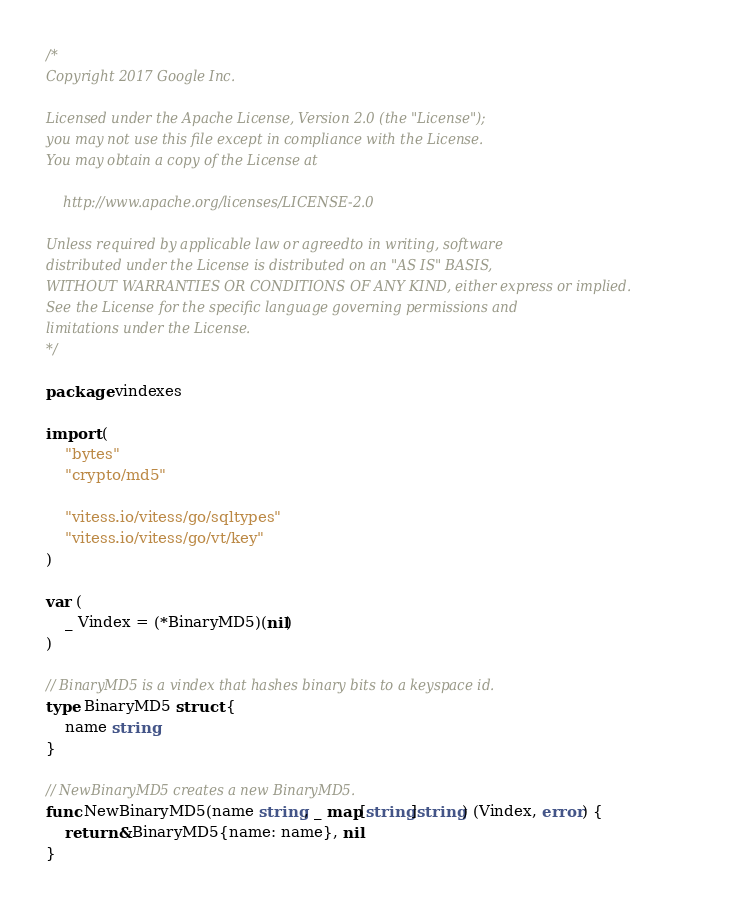Convert code to text. <code><loc_0><loc_0><loc_500><loc_500><_Go_>/*
Copyright 2017 Google Inc.

Licensed under the Apache License, Version 2.0 (the "License");
you may not use this file except in compliance with the License.
You may obtain a copy of the License at

    http://www.apache.org/licenses/LICENSE-2.0

Unless required by applicable law or agreedto in writing, software
distributed under the License is distributed on an "AS IS" BASIS,
WITHOUT WARRANTIES OR CONDITIONS OF ANY KIND, either express or implied.
See the License for the specific language governing permissions and
limitations under the License.
*/

package vindexes

import (
	"bytes"
	"crypto/md5"

	"vitess.io/vitess/go/sqltypes"
	"vitess.io/vitess/go/vt/key"
)

var (
	_ Vindex = (*BinaryMD5)(nil)
)

// BinaryMD5 is a vindex that hashes binary bits to a keyspace id.
type BinaryMD5 struct {
	name string
}

// NewBinaryMD5 creates a new BinaryMD5.
func NewBinaryMD5(name string, _ map[string]string) (Vindex, error) {
	return &BinaryMD5{name: name}, nil
}
</code> 